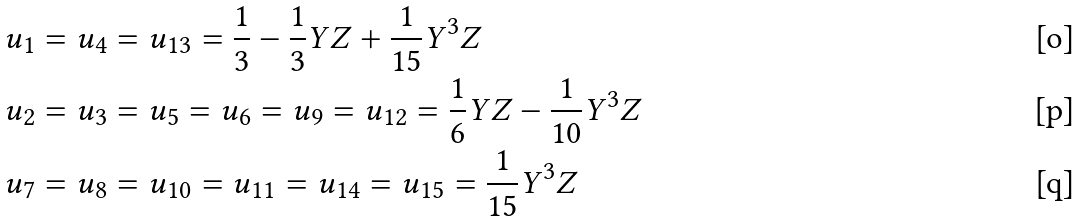Convert formula to latex. <formula><loc_0><loc_0><loc_500><loc_500>u _ { 1 } & = u _ { 4 } = u _ { 1 3 } = \frac { 1 } { 3 } - \frac { 1 } { 3 } Y Z + \frac { 1 } { 1 5 } Y ^ { 3 } Z \\ u _ { 2 } & = u _ { 3 } = u _ { 5 } = u _ { 6 } = u _ { 9 } = u _ { 1 2 } = \frac { 1 } { 6 } Y Z - \frac { 1 } { 1 0 } Y ^ { 3 } Z \\ u _ { 7 } & = u _ { 8 } = u _ { 1 0 } = u _ { 1 1 } = u _ { 1 4 } = u _ { 1 5 } = \frac { 1 } { 1 5 } Y ^ { 3 } Z</formula> 